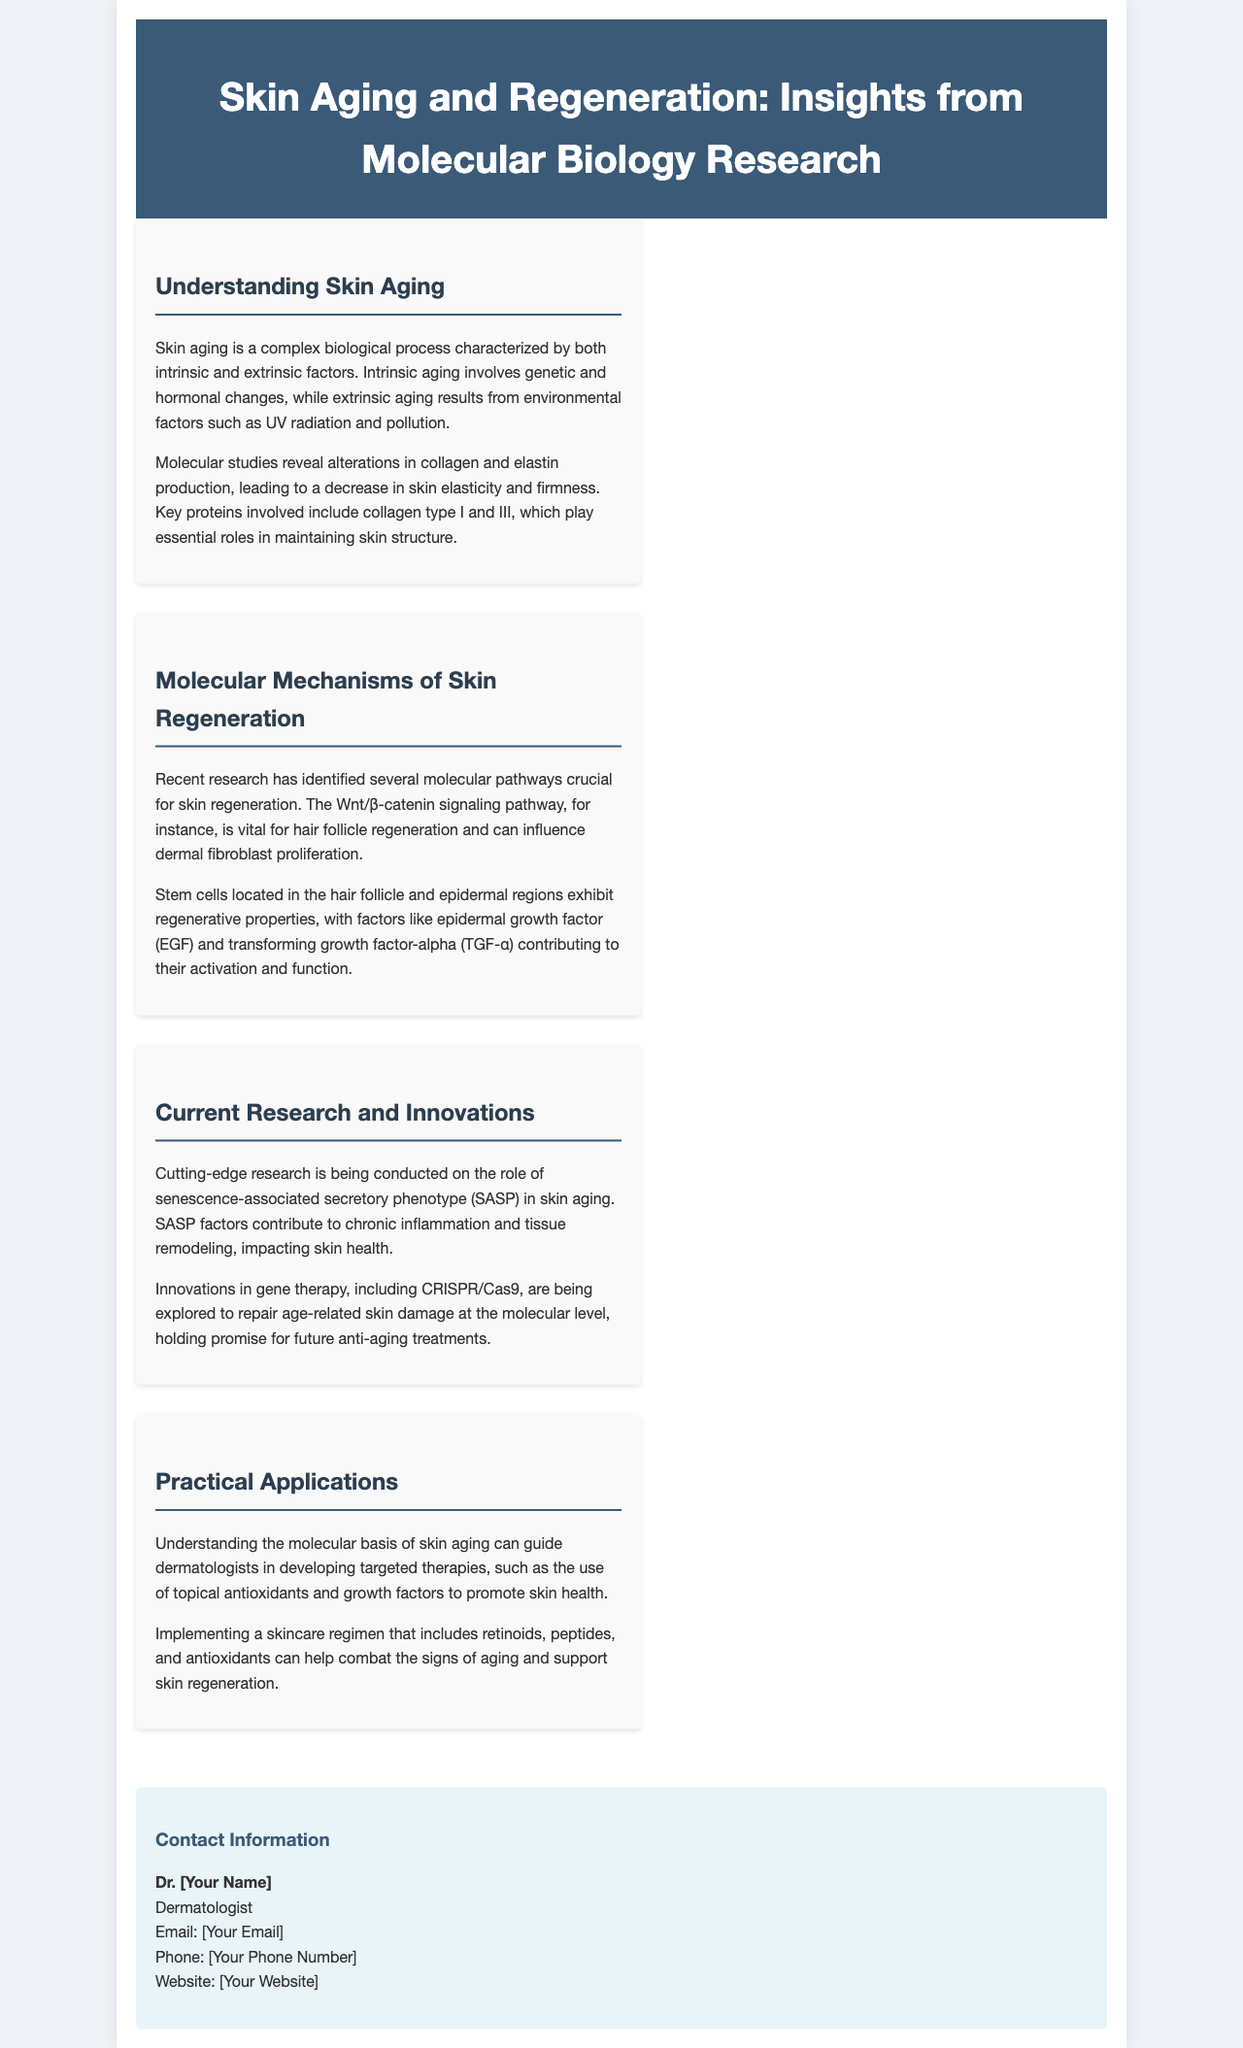What are the two types of skin aging? The brochure mentions intrinsic and extrinsic factors as the two types of skin aging.
Answer: Intrinsic and extrinsic Which proteins are key in maintaining skin structure? The document specifies collagen type I and III as essential for skin structure.
Answer: Collagen type I and III What signaling pathway is vital for hair follicle regeneration? The Wnt/β-catenin signaling pathway is highlighted as critical for hair follicle regeneration.
Answer: Wnt/β-catenin What innovative technology is being explored for skin aging treatments? The brochure discusses the use of CRISPR/Cas9 in the context of age-related skin damage repair.
Answer: CRISPR/Cas9 What contributes to chronic inflammation in skin aging? The senescence-associated secretory phenotype (SASP) is mentioned as a factor contributing to chronic inflammation.
Answer: SASP 